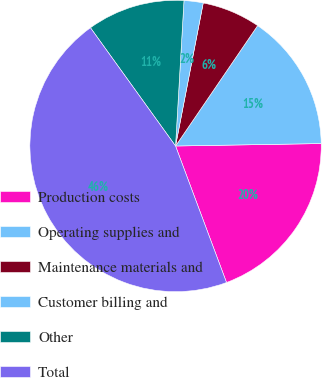<chart> <loc_0><loc_0><loc_500><loc_500><pie_chart><fcel>Production costs<fcel>Operating supplies and<fcel>Maintenance materials and<fcel>Customer billing and<fcel>Other<fcel>Total<nl><fcel>19.58%<fcel>15.21%<fcel>6.48%<fcel>2.12%<fcel>10.85%<fcel>45.76%<nl></chart> 